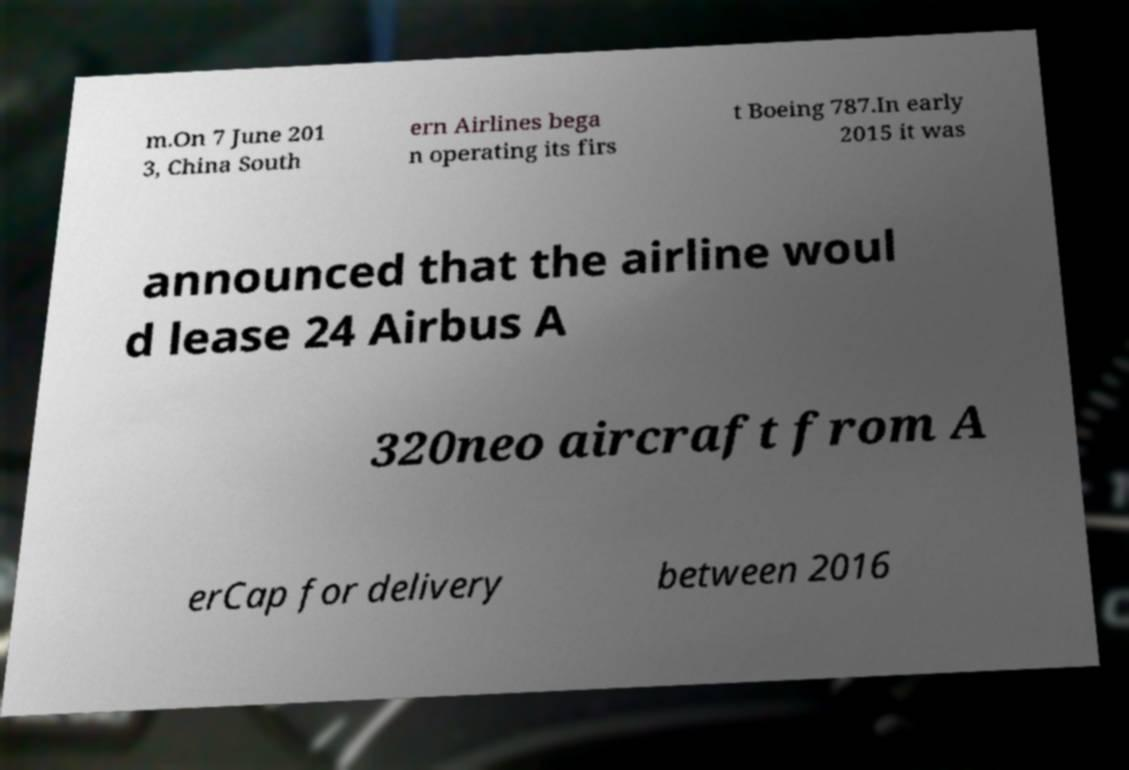Can you accurately transcribe the text from the provided image for me? m.On 7 June 201 3, China South ern Airlines bega n operating its firs t Boeing 787.In early 2015 it was announced that the airline woul d lease 24 Airbus A 320neo aircraft from A erCap for delivery between 2016 